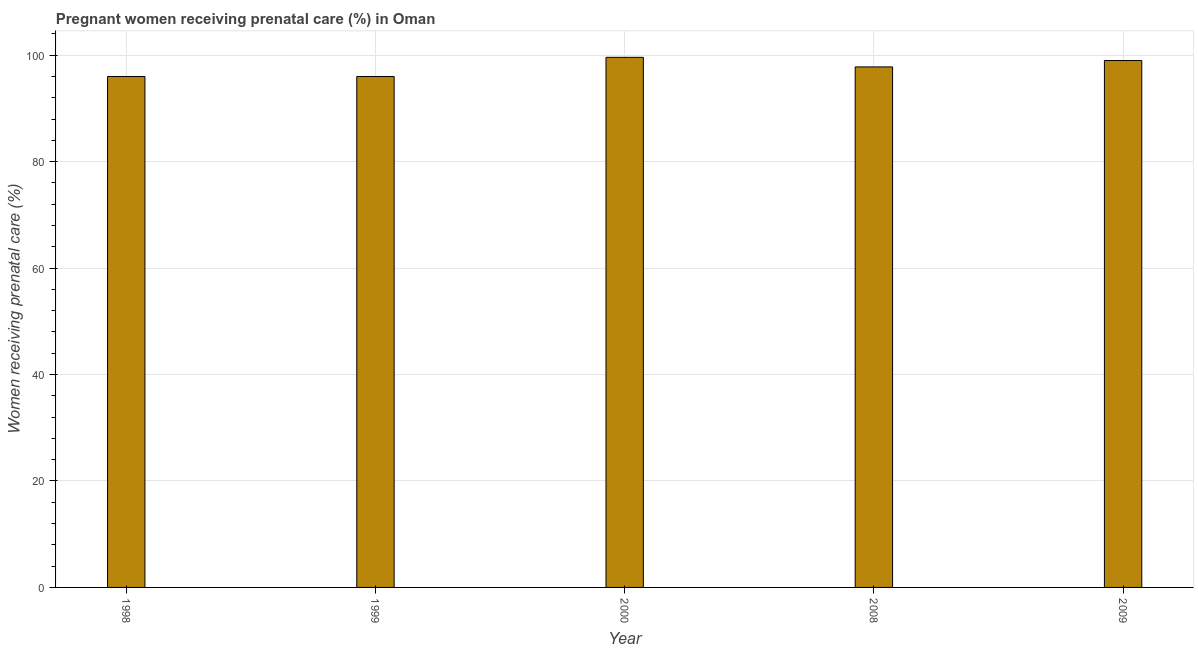Does the graph contain grids?
Your response must be concise. Yes. What is the title of the graph?
Your answer should be compact. Pregnant women receiving prenatal care (%) in Oman. What is the label or title of the Y-axis?
Ensure brevity in your answer.  Women receiving prenatal care (%). What is the percentage of pregnant women receiving prenatal care in 2000?
Provide a short and direct response. 99.6. Across all years, what is the maximum percentage of pregnant women receiving prenatal care?
Offer a terse response. 99.6. Across all years, what is the minimum percentage of pregnant women receiving prenatal care?
Provide a succinct answer. 96. In which year was the percentage of pregnant women receiving prenatal care maximum?
Provide a short and direct response. 2000. In which year was the percentage of pregnant women receiving prenatal care minimum?
Provide a succinct answer. 1998. What is the sum of the percentage of pregnant women receiving prenatal care?
Make the answer very short. 488.4. What is the difference between the percentage of pregnant women receiving prenatal care in 1999 and 2000?
Keep it short and to the point. -3.6. What is the average percentage of pregnant women receiving prenatal care per year?
Your response must be concise. 97.68. What is the median percentage of pregnant women receiving prenatal care?
Offer a terse response. 97.8. Do a majority of the years between 1998 and 2009 (inclusive) have percentage of pregnant women receiving prenatal care greater than 32 %?
Make the answer very short. Yes. Is the difference between the percentage of pregnant women receiving prenatal care in 1999 and 2000 greater than the difference between any two years?
Provide a succinct answer. Yes. Is the sum of the percentage of pregnant women receiving prenatal care in 1998 and 2008 greater than the maximum percentage of pregnant women receiving prenatal care across all years?
Your answer should be very brief. Yes. In how many years, is the percentage of pregnant women receiving prenatal care greater than the average percentage of pregnant women receiving prenatal care taken over all years?
Keep it short and to the point. 3. How many bars are there?
Offer a terse response. 5. Are all the bars in the graph horizontal?
Give a very brief answer. No. Are the values on the major ticks of Y-axis written in scientific E-notation?
Provide a succinct answer. No. What is the Women receiving prenatal care (%) in 1998?
Offer a very short reply. 96. What is the Women receiving prenatal care (%) of 1999?
Your response must be concise. 96. What is the Women receiving prenatal care (%) of 2000?
Your answer should be very brief. 99.6. What is the Women receiving prenatal care (%) of 2008?
Offer a terse response. 97.8. What is the Women receiving prenatal care (%) of 2009?
Your answer should be very brief. 99. What is the difference between the Women receiving prenatal care (%) in 1998 and 2000?
Provide a succinct answer. -3.6. What is the difference between the Women receiving prenatal care (%) in 1999 and 2000?
Ensure brevity in your answer.  -3.6. What is the difference between the Women receiving prenatal care (%) in 1999 and 2008?
Provide a succinct answer. -1.8. What is the difference between the Women receiving prenatal care (%) in 2000 and 2008?
Your answer should be compact. 1.8. What is the difference between the Women receiving prenatal care (%) in 2000 and 2009?
Your answer should be very brief. 0.6. What is the ratio of the Women receiving prenatal care (%) in 1998 to that in 2000?
Give a very brief answer. 0.96. What is the ratio of the Women receiving prenatal care (%) in 1998 to that in 2008?
Ensure brevity in your answer.  0.98. What is the ratio of the Women receiving prenatal care (%) in 1999 to that in 2000?
Provide a succinct answer. 0.96. What is the ratio of the Women receiving prenatal care (%) in 1999 to that in 2008?
Offer a very short reply. 0.98. What is the ratio of the Women receiving prenatal care (%) in 1999 to that in 2009?
Keep it short and to the point. 0.97. 